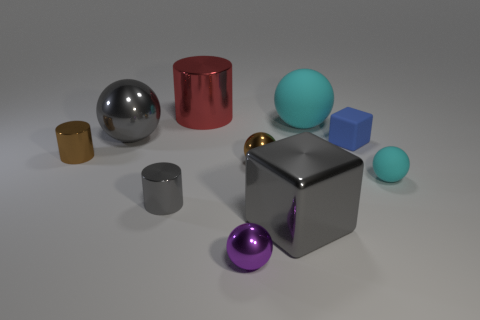Does the small matte ball have the same color as the tiny block?
Give a very brief answer. No. What number of other objects are the same color as the large rubber object?
Make the answer very short. 1. How many large cyan matte things have the same shape as the purple metallic object?
Ensure brevity in your answer.  1. What size is the gray cylinder that is the same material as the purple object?
Provide a short and direct response. Small. Is the number of big metallic things greater than the number of purple matte objects?
Offer a very short reply. Yes. There is a block behind the small gray cylinder; what color is it?
Provide a succinct answer. Blue. What size is the shiny thing that is behind the gray cylinder and to the right of the tiny purple object?
Offer a very short reply. Small. What number of gray spheres have the same size as the purple object?
Your response must be concise. 0. What is the material of the brown object that is the same shape as the purple shiny object?
Offer a very short reply. Metal. Is the large rubber thing the same shape as the small blue matte thing?
Give a very brief answer. No. 